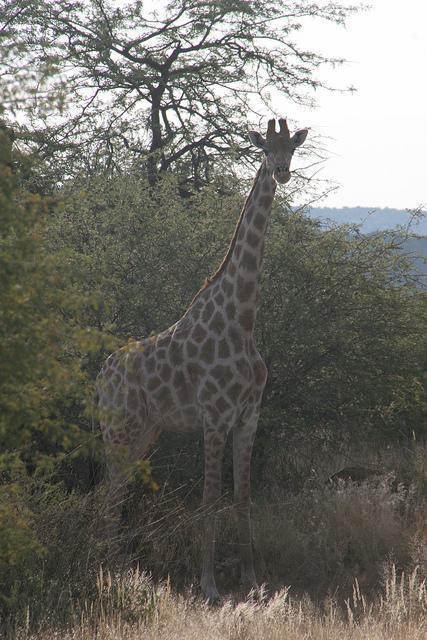How many vehicles are in this photo?
Give a very brief answer. 0. How many giraffes in the picture?
Give a very brief answer. 1. How many giraffes are in this photo?
Give a very brief answer. 1. 